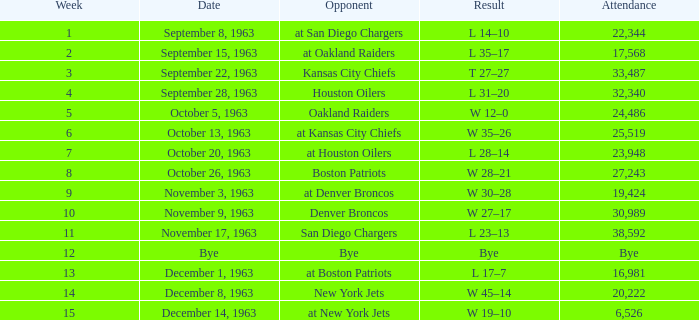In which match-up, does one of the opponents have a 14-10 result? At san diego chargers. 